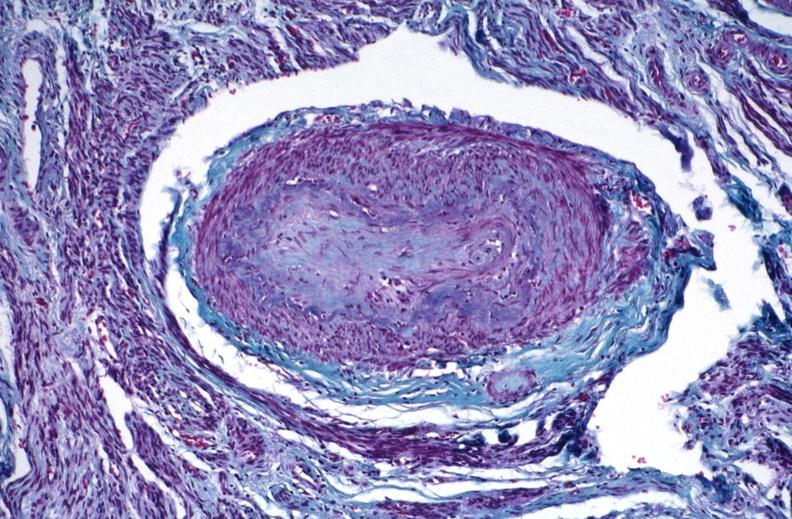do thrichrome stain?
Answer the question using a single word or phrase. Yes 